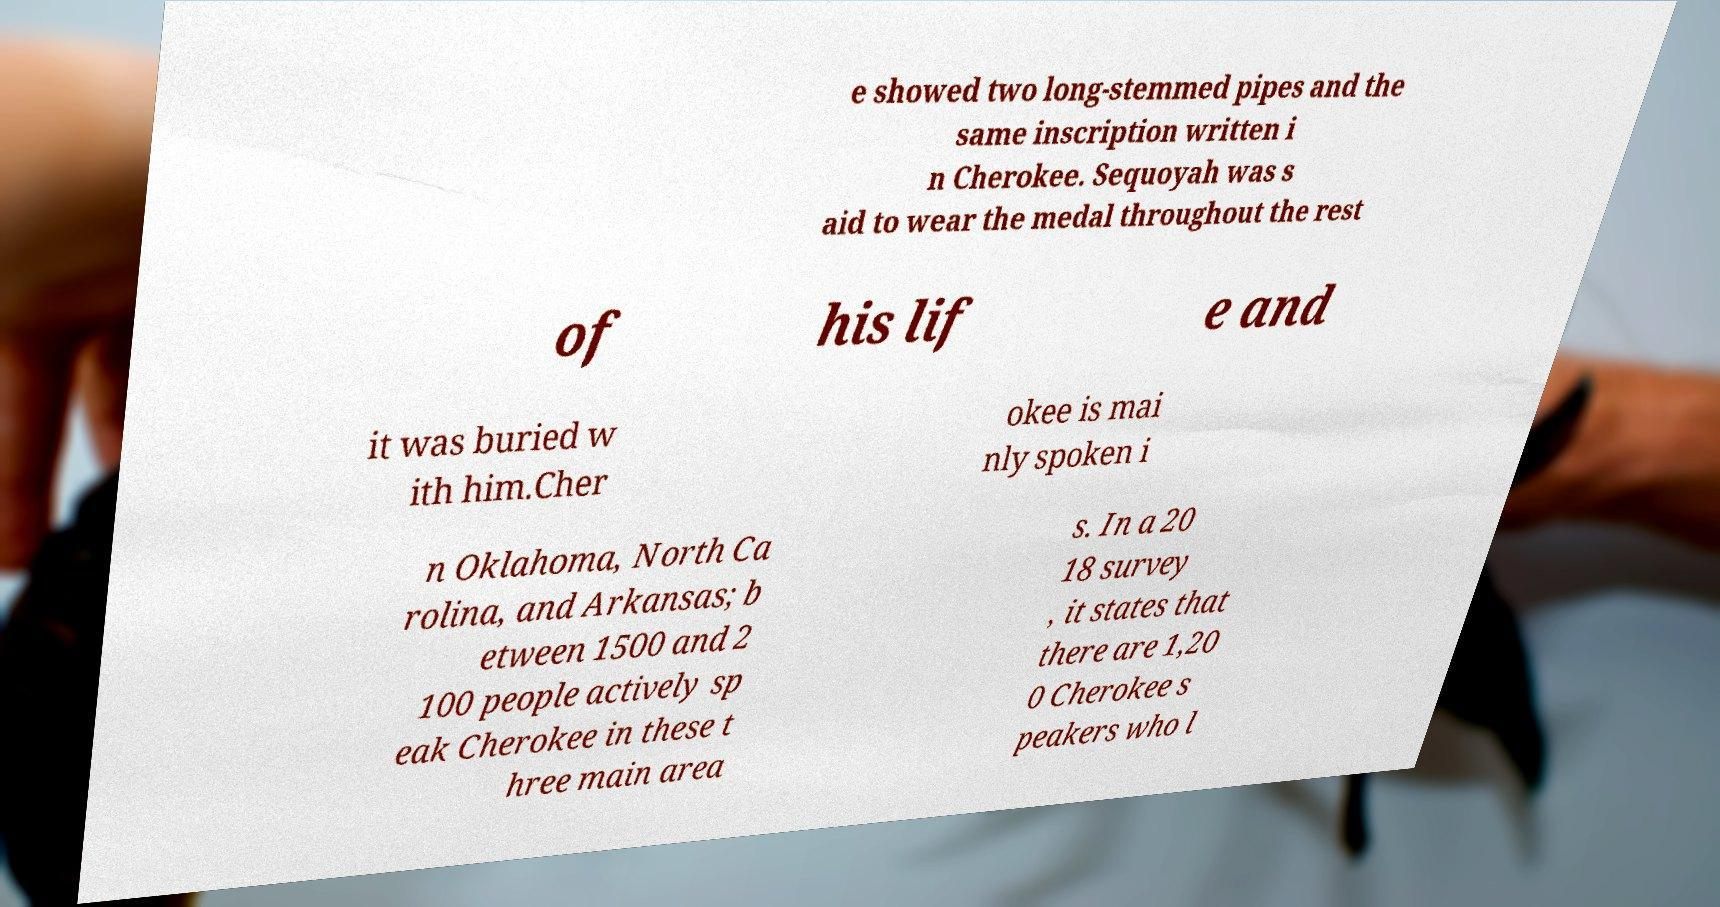There's text embedded in this image that I need extracted. Can you transcribe it verbatim? e showed two long-stemmed pipes and the same inscription written i n Cherokee. Sequoyah was s aid to wear the medal throughout the rest of his lif e and it was buried w ith him.Cher okee is mai nly spoken i n Oklahoma, North Ca rolina, and Arkansas; b etween 1500 and 2 100 people actively sp eak Cherokee in these t hree main area s. In a 20 18 survey , it states that there are 1,20 0 Cherokee s peakers who l 